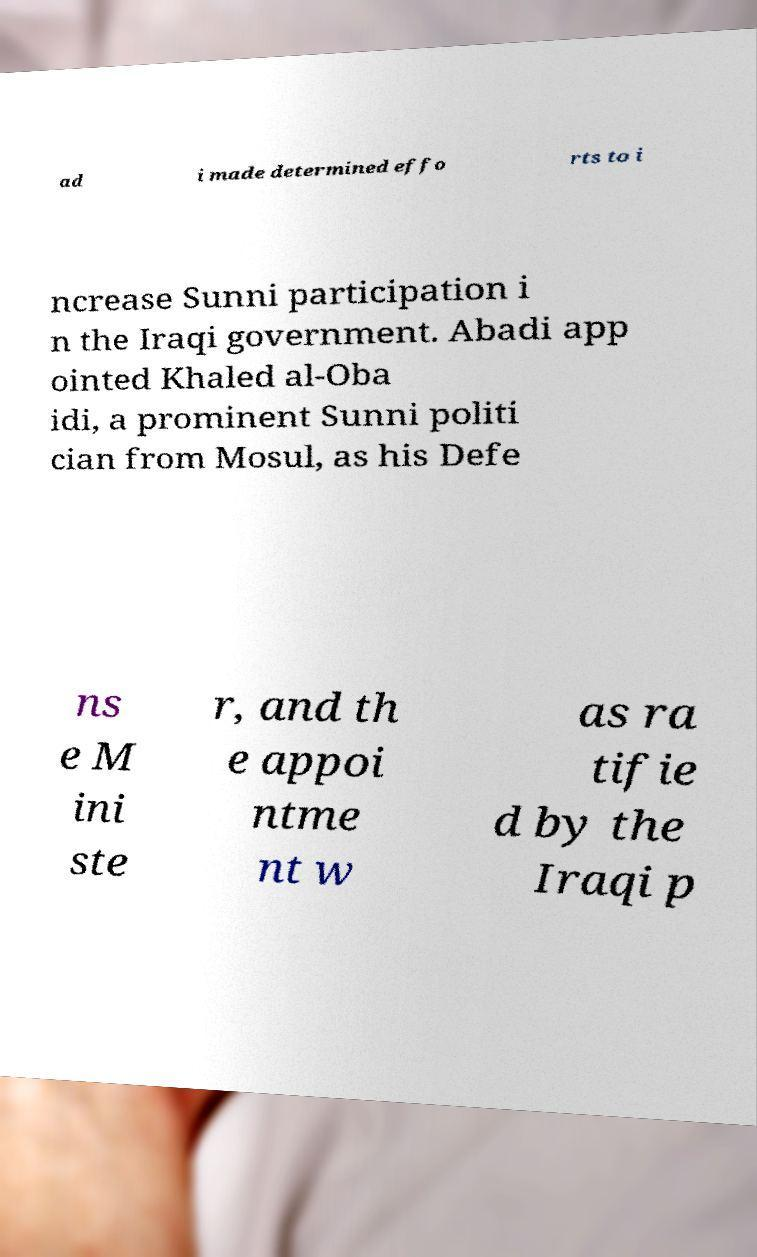What messages or text are displayed in this image? I need them in a readable, typed format. ad i made determined effo rts to i ncrease Sunni participation i n the Iraqi government. Abadi app ointed Khaled al-Oba idi, a prominent Sunni politi cian from Mosul, as his Defe ns e M ini ste r, and th e appoi ntme nt w as ra tifie d by the Iraqi p 